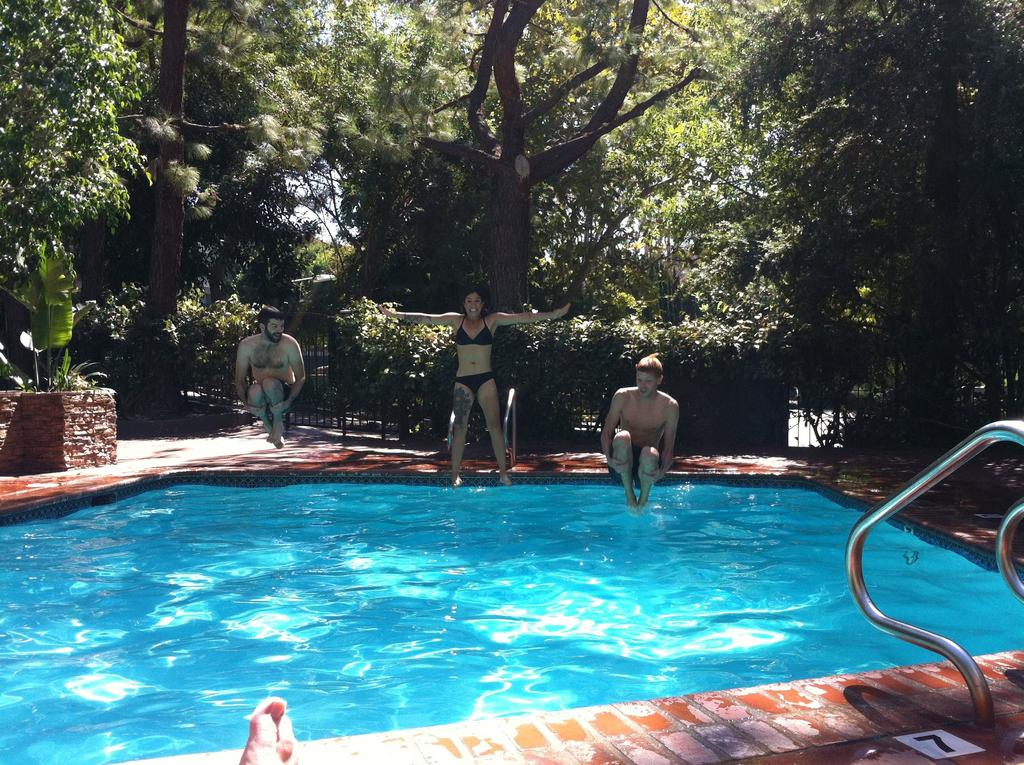What is the main feature of the image? There is a swimming pool in the image. What are the man and woman doing in the image? The man and woman are jumping into the water in the swimming pool. Can you describe the person near the pool? There is a man seated near the pool. What can be seen in the background of the image? Trees are visible in the image. Whose leg is visible in the image? There is a human leg visible in the image, but it is not specified whose leg it is. What can be used for climbing in the image? Metal rods for climbing are present in the image. What type of store can be seen in the image? There is no store present in the image; it features a swimming pool and people jumping into the water. What caption would you suggest for this image? It is not possible to suggest a caption without knowing the context or purpose of the image. 